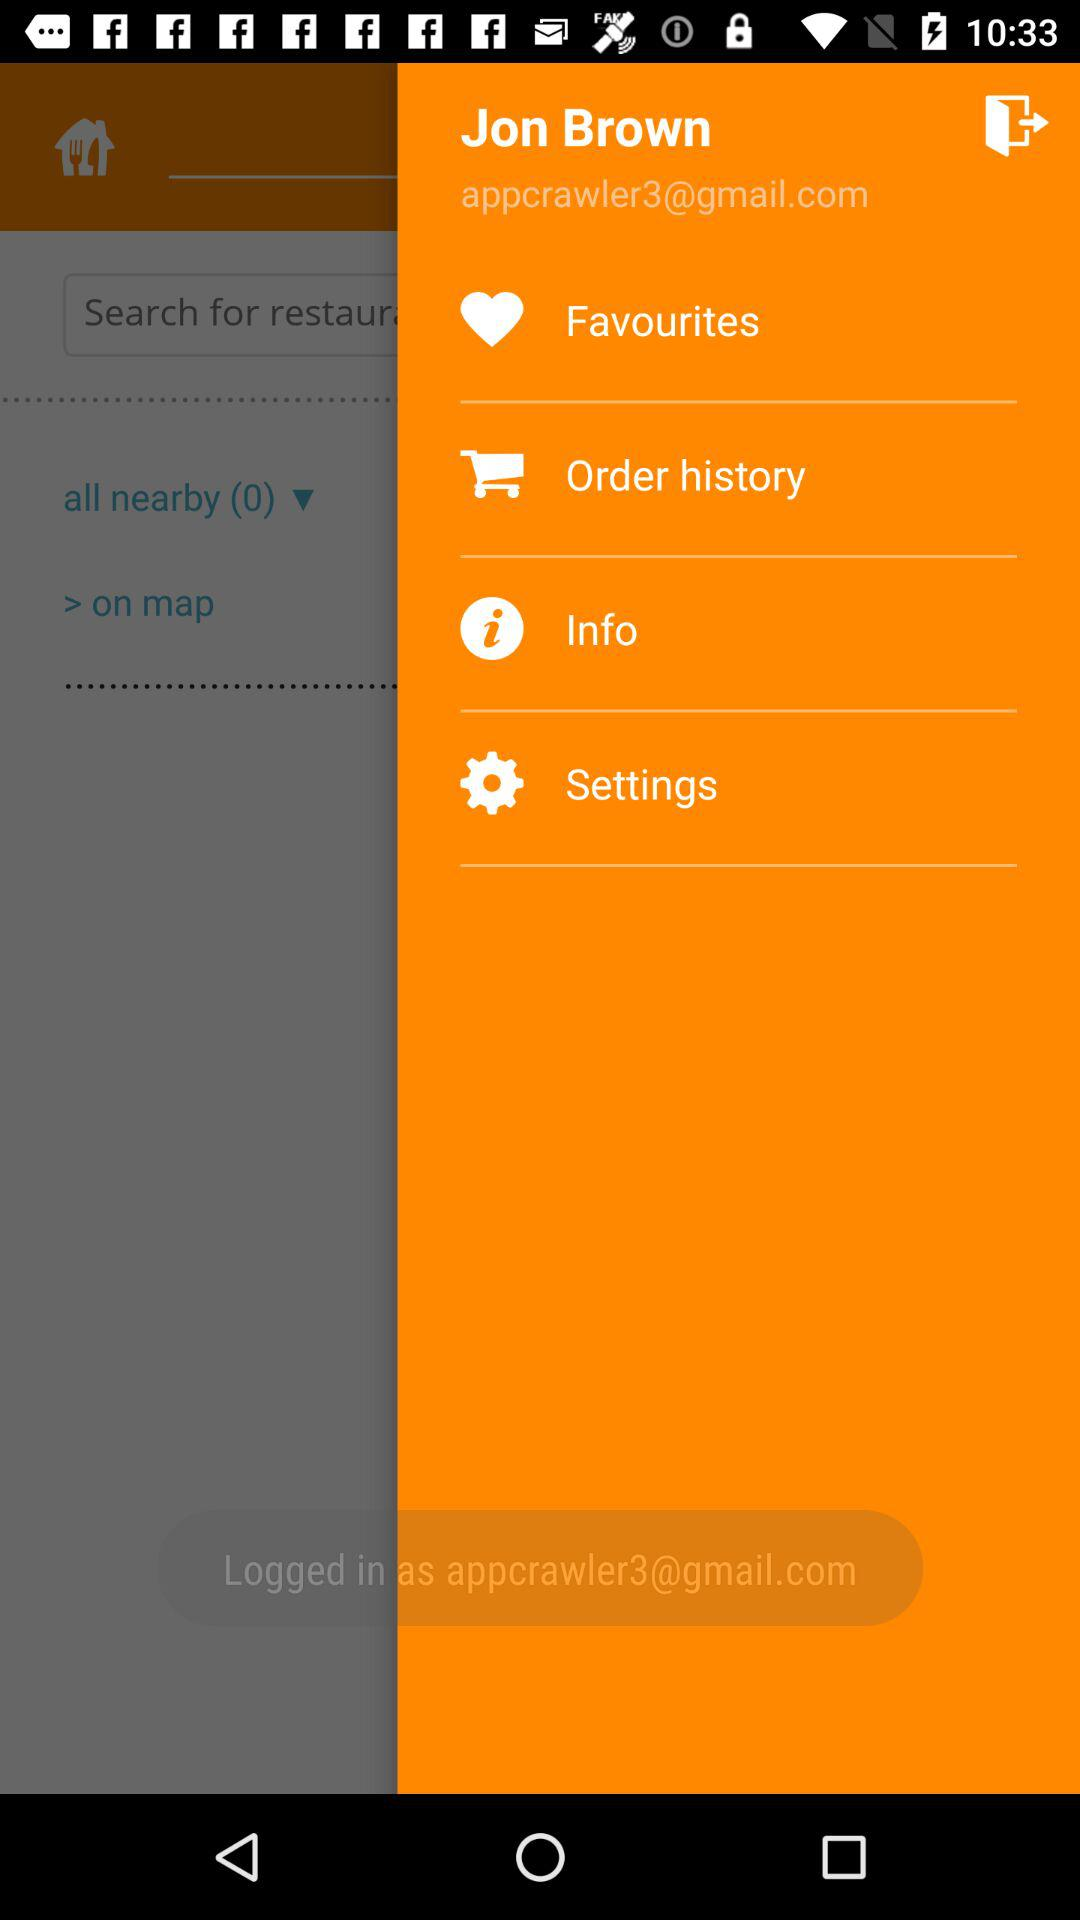What Gmail address is used? The used Gmail address is appcrawler3@gmail.com. 